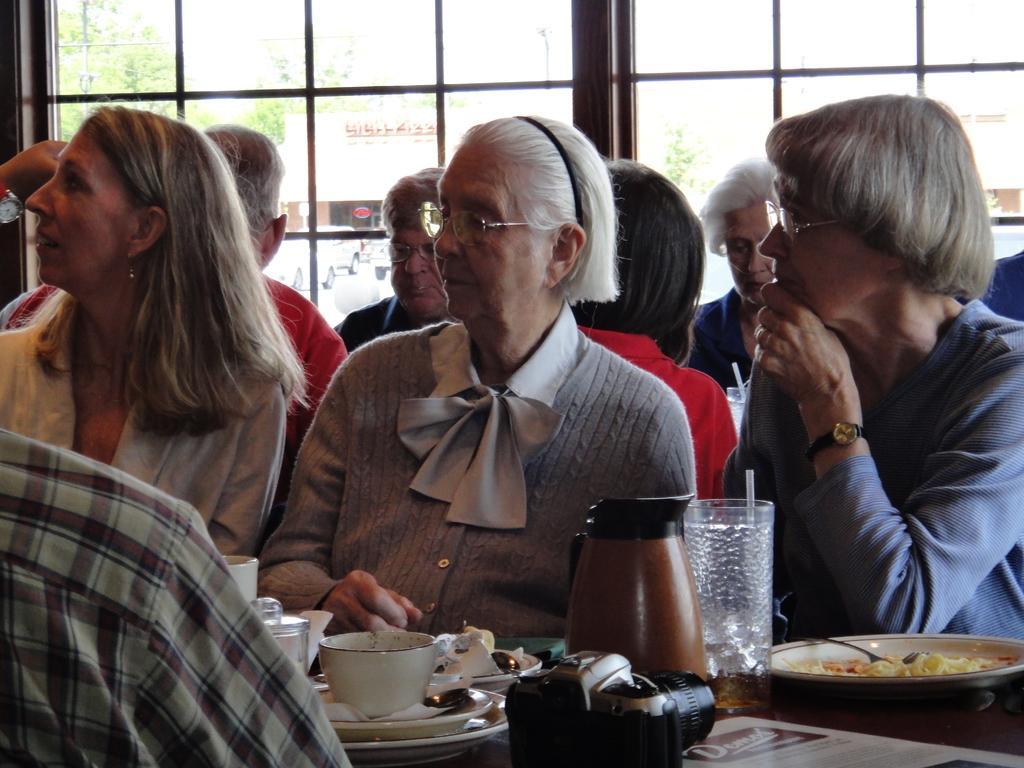How would you summarize this image in a sentence or two? In this image we can see few persons are sitting on the chairs at the table and on the table we can see food items in the plates, bowl, jug, camera, glass with liquid in it and objects. In the background we can see few persons are sitting at the window. Through the window glass doors we can see buildings, vehicles on the road, trees and sky. 